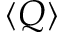<formula> <loc_0><loc_0><loc_500><loc_500>\langle { Q } \rangle</formula> 